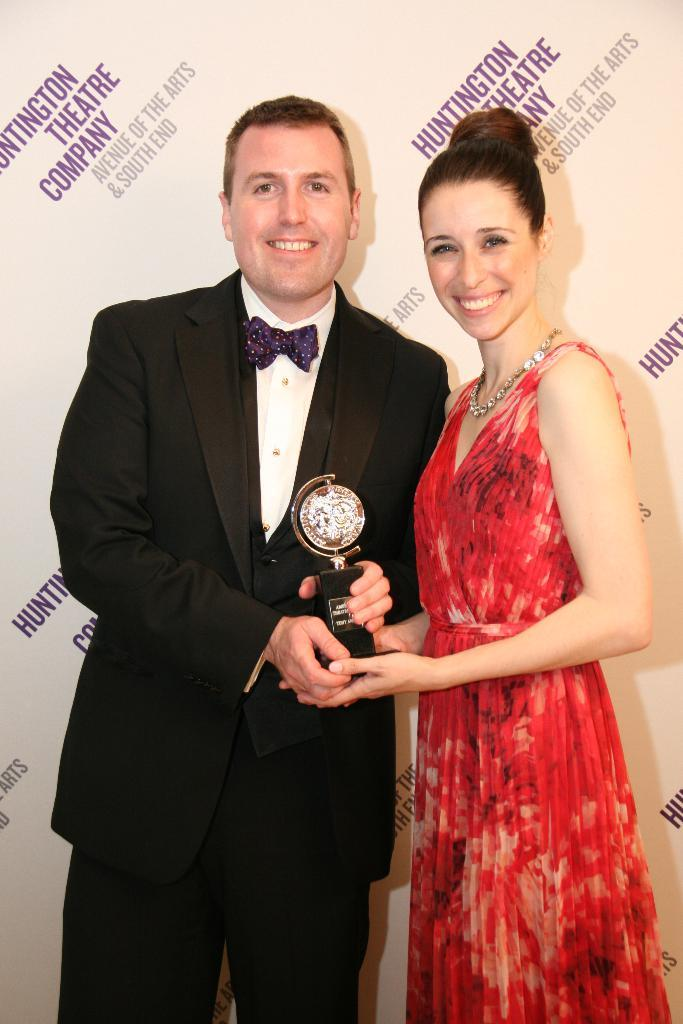<image>
Provide a brief description of the given image. A couple stands in front of a wall that says Huntington Theatre Company in purple letters. 